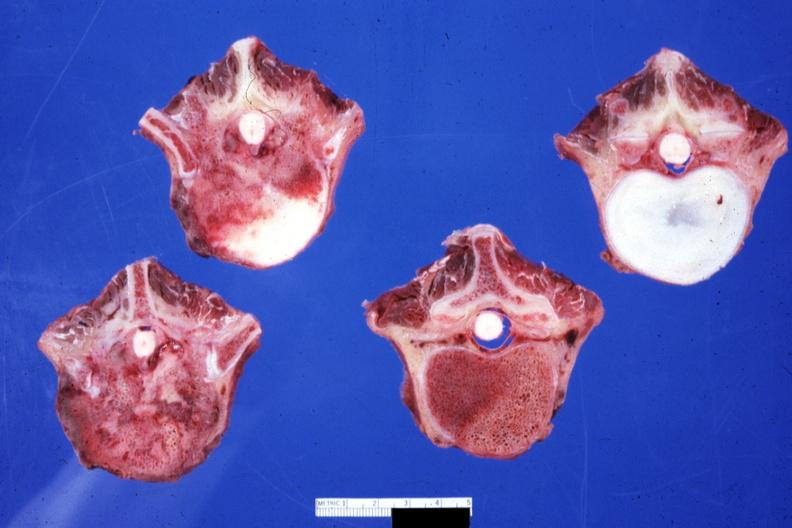does this image show obvious metastatic lesions primary in mediastinum 20yowm?
Answer the question using a single word or phrase. Yes 